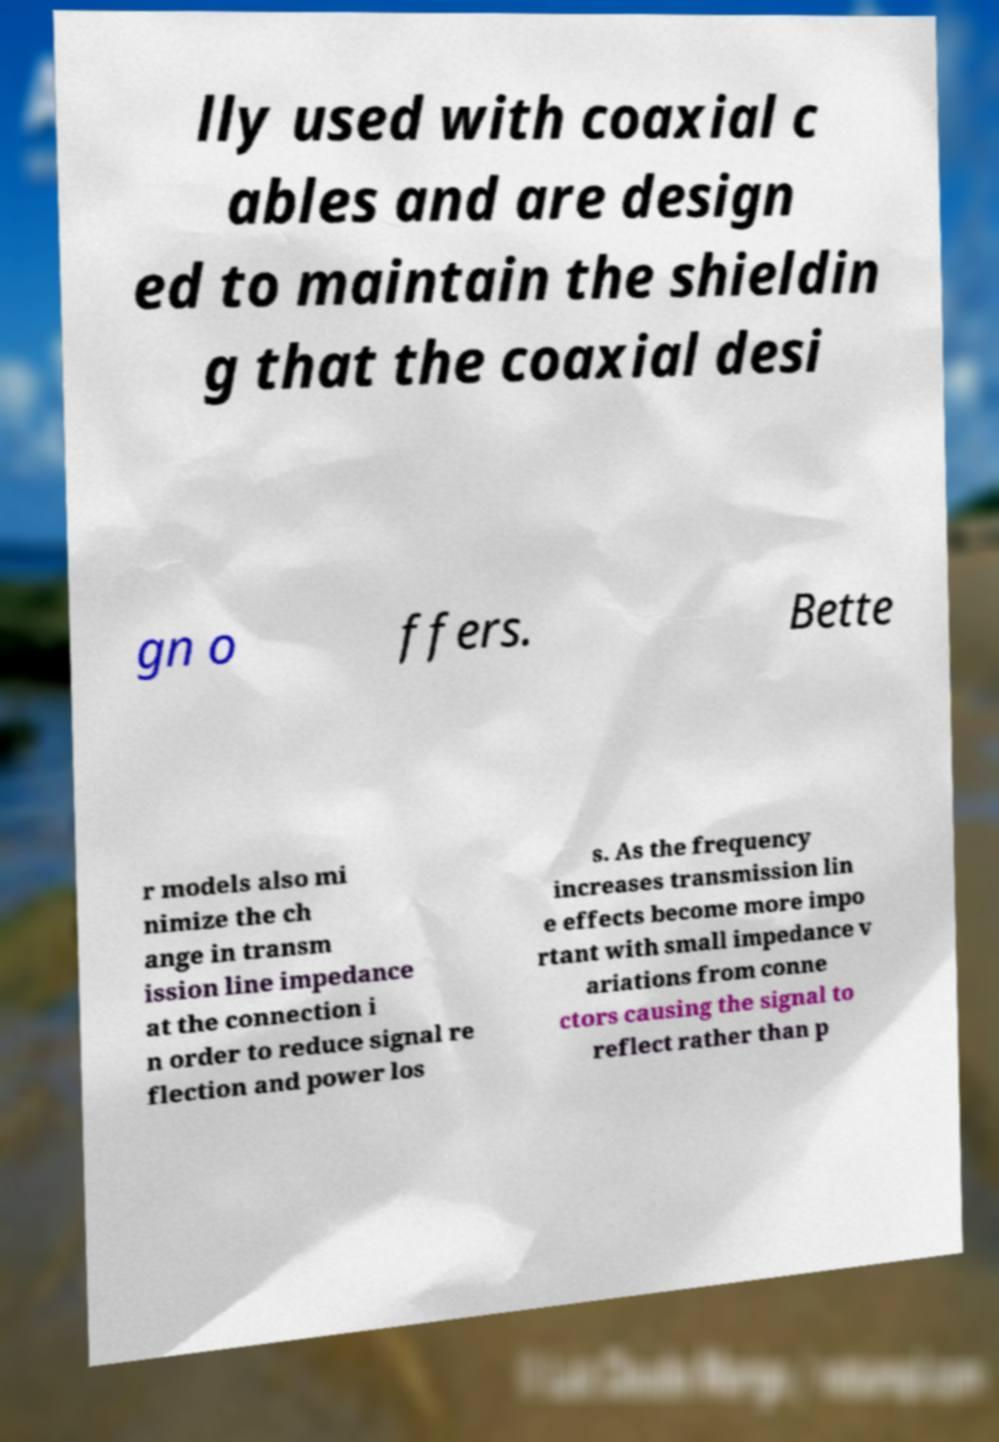Please identify and transcribe the text found in this image. lly used with coaxial c ables and are design ed to maintain the shieldin g that the coaxial desi gn o ffers. Bette r models also mi nimize the ch ange in transm ission line impedance at the connection i n order to reduce signal re flection and power los s. As the frequency increases transmission lin e effects become more impo rtant with small impedance v ariations from conne ctors causing the signal to reflect rather than p 